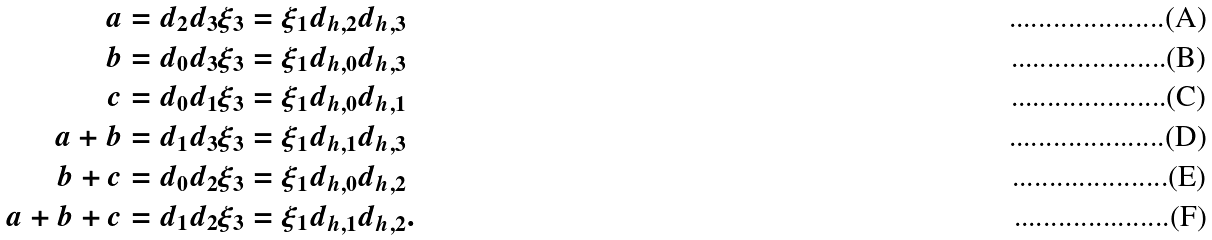Convert formula to latex. <formula><loc_0><loc_0><loc_500><loc_500>a & = d _ { 2 } d _ { 3 } \xi _ { 3 } = \xi _ { 1 } d _ { h , 2 } d _ { h , 3 } \\ b & = d _ { 0 } d _ { 3 } \xi _ { 3 } = \xi _ { 1 } d _ { h , 0 } d _ { h , 3 } \\ c & = d _ { 0 } d _ { 1 } \xi _ { 3 } = \xi _ { 1 } d _ { h , 0 } d _ { h , 1 } \\ a + b & = d _ { 1 } d _ { 3 } \xi _ { 3 } = \xi _ { 1 } d _ { h , 1 } d _ { h , 3 } \\ b + c & = d _ { 0 } d _ { 2 } \xi _ { 3 } = \xi _ { 1 } d _ { h , 0 } d _ { h , 2 } \\ a + b + c & = d _ { 1 } d _ { 2 } \xi _ { 3 } = \xi _ { 1 } d _ { h , 1 } d _ { h , 2 } .</formula> 